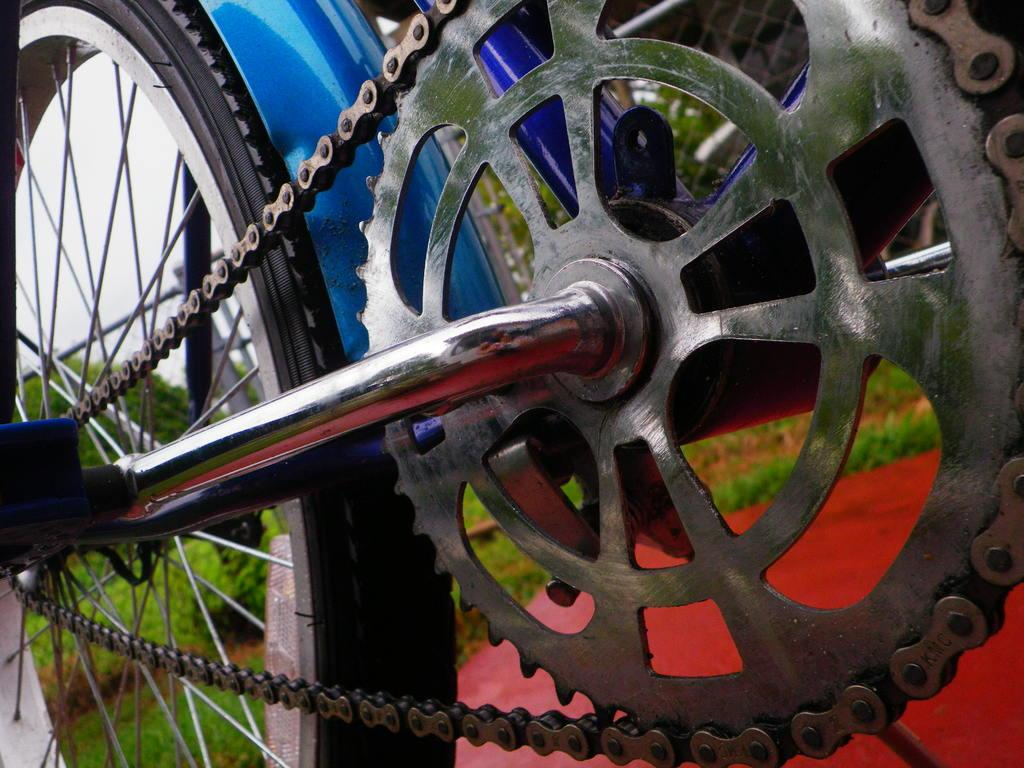What is the main object in the center of the image? There is a cycle in the center of the image. What can be seen in the background of the image? There are trees, plants, grass, and the sky visible in the background of the image. What type of ink is being used to draw the cattle in the image? There are no cattle present in the image, and therefore no ink or drawing can be observed. 